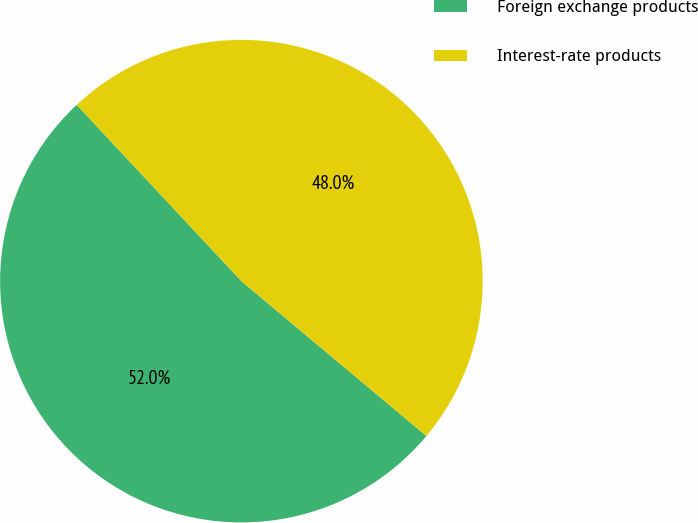<chart> <loc_0><loc_0><loc_500><loc_500><pie_chart><fcel>Foreign exchange products<fcel>Interest-rate products<nl><fcel>51.95%<fcel>48.05%<nl></chart> 